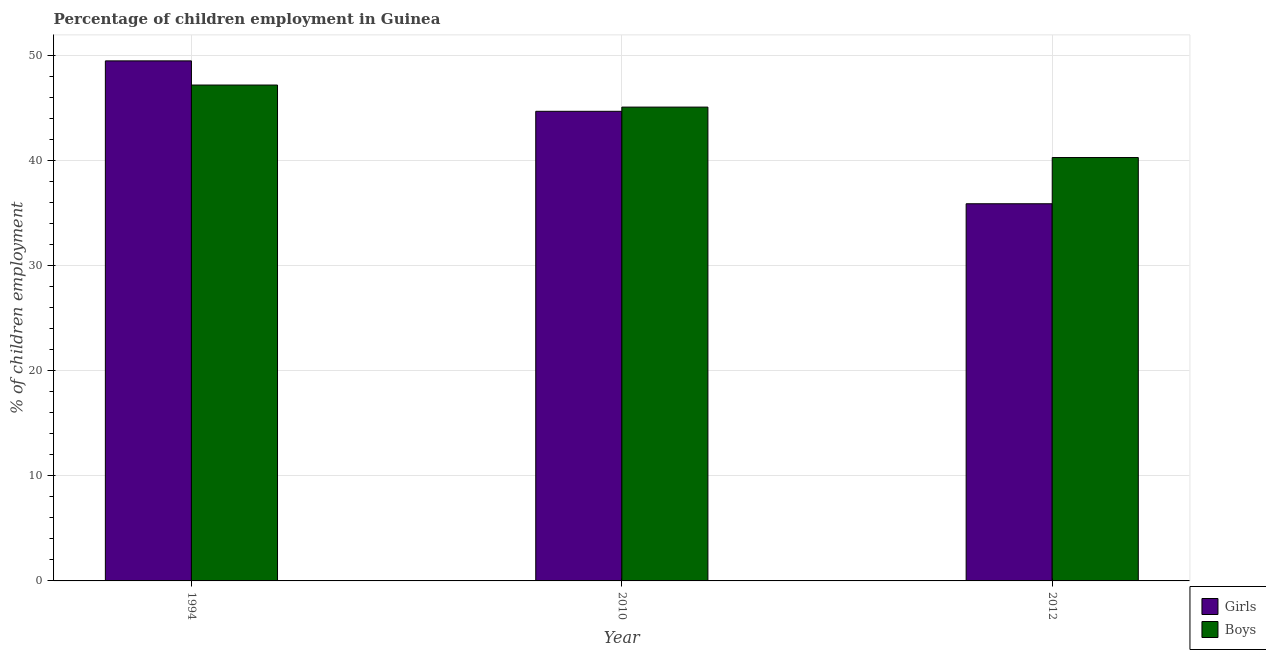How many groups of bars are there?
Your response must be concise. 3. Are the number of bars per tick equal to the number of legend labels?
Ensure brevity in your answer.  Yes. How many bars are there on the 3rd tick from the left?
Provide a succinct answer. 2. How many bars are there on the 3rd tick from the right?
Ensure brevity in your answer.  2. What is the percentage of employed boys in 1994?
Make the answer very short. 47.2. Across all years, what is the maximum percentage of employed boys?
Give a very brief answer. 47.2. Across all years, what is the minimum percentage of employed girls?
Provide a succinct answer. 35.9. What is the total percentage of employed boys in the graph?
Offer a terse response. 132.6. What is the difference between the percentage of employed girls in 2010 and that in 2012?
Provide a short and direct response. 8.8. What is the difference between the percentage of employed boys in 2012 and the percentage of employed girls in 2010?
Make the answer very short. -4.8. What is the average percentage of employed girls per year?
Give a very brief answer. 43.37. In the year 2010, what is the difference between the percentage of employed girls and percentage of employed boys?
Provide a short and direct response. 0. What is the ratio of the percentage of employed girls in 2010 to that in 2012?
Provide a succinct answer. 1.25. Is the difference between the percentage of employed boys in 1994 and 2010 greater than the difference between the percentage of employed girls in 1994 and 2010?
Your answer should be very brief. No. What is the difference between the highest and the second highest percentage of employed boys?
Provide a short and direct response. 2.1. What is the difference between the highest and the lowest percentage of employed girls?
Give a very brief answer. 13.6. In how many years, is the percentage of employed boys greater than the average percentage of employed boys taken over all years?
Your answer should be very brief. 2. Is the sum of the percentage of employed girls in 1994 and 2010 greater than the maximum percentage of employed boys across all years?
Your response must be concise. Yes. What does the 1st bar from the left in 1994 represents?
Give a very brief answer. Girls. What does the 2nd bar from the right in 2012 represents?
Offer a very short reply. Girls. How many bars are there?
Your response must be concise. 6. How many years are there in the graph?
Provide a succinct answer. 3. What is the difference between two consecutive major ticks on the Y-axis?
Provide a short and direct response. 10. Does the graph contain any zero values?
Your answer should be compact. No. Where does the legend appear in the graph?
Offer a terse response. Bottom right. What is the title of the graph?
Give a very brief answer. Percentage of children employment in Guinea. What is the label or title of the Y-axis?
Offer a terse response. % of children employment. What is the % of children employment in Girls in 1994?
Your response must be concise. 49.5. What is the % of children employment in Boys in 1994?
Offer a terse response. 47.2. What is the % of children employment in Girls in 2010?
Your answer should be very brief. 44.7. What is the % of children employment in Boys in 2010?
Offer a terse response. 45.1. What is the % of children employment of Girls in 2012?
Your response must be concise. 35.9. What is the % of children employment of Boys in 2012?
Your answer should be compact. 40.3. Across all years, what is the maximum % of children employment in Girls?
Offer a terse response. 49.5. Across all years, what is the maximum % of children employment in Boys?
Make the answer very short. 47.2. Across all years, what is the minimum % of children employment in Girls?
Your answer should be very brief. 35.9. Across all years, what is the minimum % of children employment of Boys?
Provide a short and direct response. 40.3. What is the total % of children employment of Girls in the graph?
Provide a short and direct response. 130.1. What is the total % of children employment of Boys in the graph?
Provide a short and direct response. 132.6. What is the difference between the % of children employment of Girls in 1994 and that in 2010?
Ensure brevity in your answer.  4.8. What is the difference between the % of children employment of Girls in 1994 and that in 2012?
Your answer should be very brief. 13.6. What is the difference between the % of children employment of Boys in 1994 and that in 2012?
Your response must be concise. 6.9. What is the difference between the % of children employment of Girls in 2010 and that in 2012?
Keep it short and to the point. 8.8. What is the difference between the % of children employment of Boys in 2010 and that in 2012?
Provide a short and direct response. 4.8. What is the difference between the % of children employment of Girls in 1994 and the % of children employment of Boys in 2012?
Ensure brevity in your answer.  9.2. What is the average % of children employment of Girls per year?
Your answer should be compact. 43.37. What is the average % of children employment of Boys per year?
Your answer should be compact. 44.2. In the year 1994, what is the difference between the % of children employment of Girls and % of children employment of Boys?
Keep it short and to the point. 2.3. What is the ratio of the % of children employment of Girls in 1994 to that in 2010?
Your answer should be very brief. 1.11. What is the ratio of the % of children employment in Boys in 1994 to that in 2010?
Offer a very short reply. 1.05. What is the ratio of the % of children employment in Girls in 1994 to that in 2012?
Make the answer very short. 1.38. What is the ratio of the % of children employment of Boys in 1994 to that in 2012?
Give a very brief answer. 1.17. What is the ratio of the % of children employment of Girls in 2010 to that in 2012?
Make the answer very short. 1.25. What is the ratio of the % of children employment in Boys in 2010 to that in 2012?
Your answer should be very brief. 1.12. What is the difference between the highest and the second highest % of children employment of Boys?
Your answer should be very brief. 2.1. 